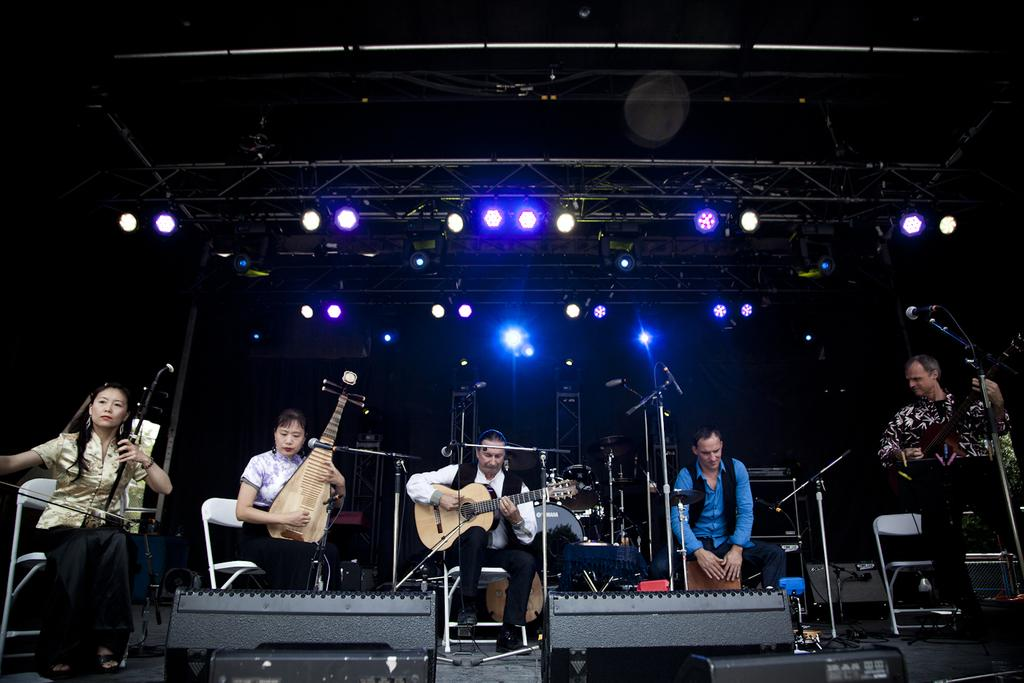How many people are present in the image? There are five people in the image, two women and three men. What are the people doing in the image? The people are sitting on chairs and playing musical instruments. Can you describe the lighting in the image? There is a light visible in the background. What type of rat can be seen playing the guitar in the image? There are no rats present in the image, and therefore no such activity can be observed. How many toes does the girl have on her left foot in the image? There is no girl present in the image, and therefore no toes can be counted. 